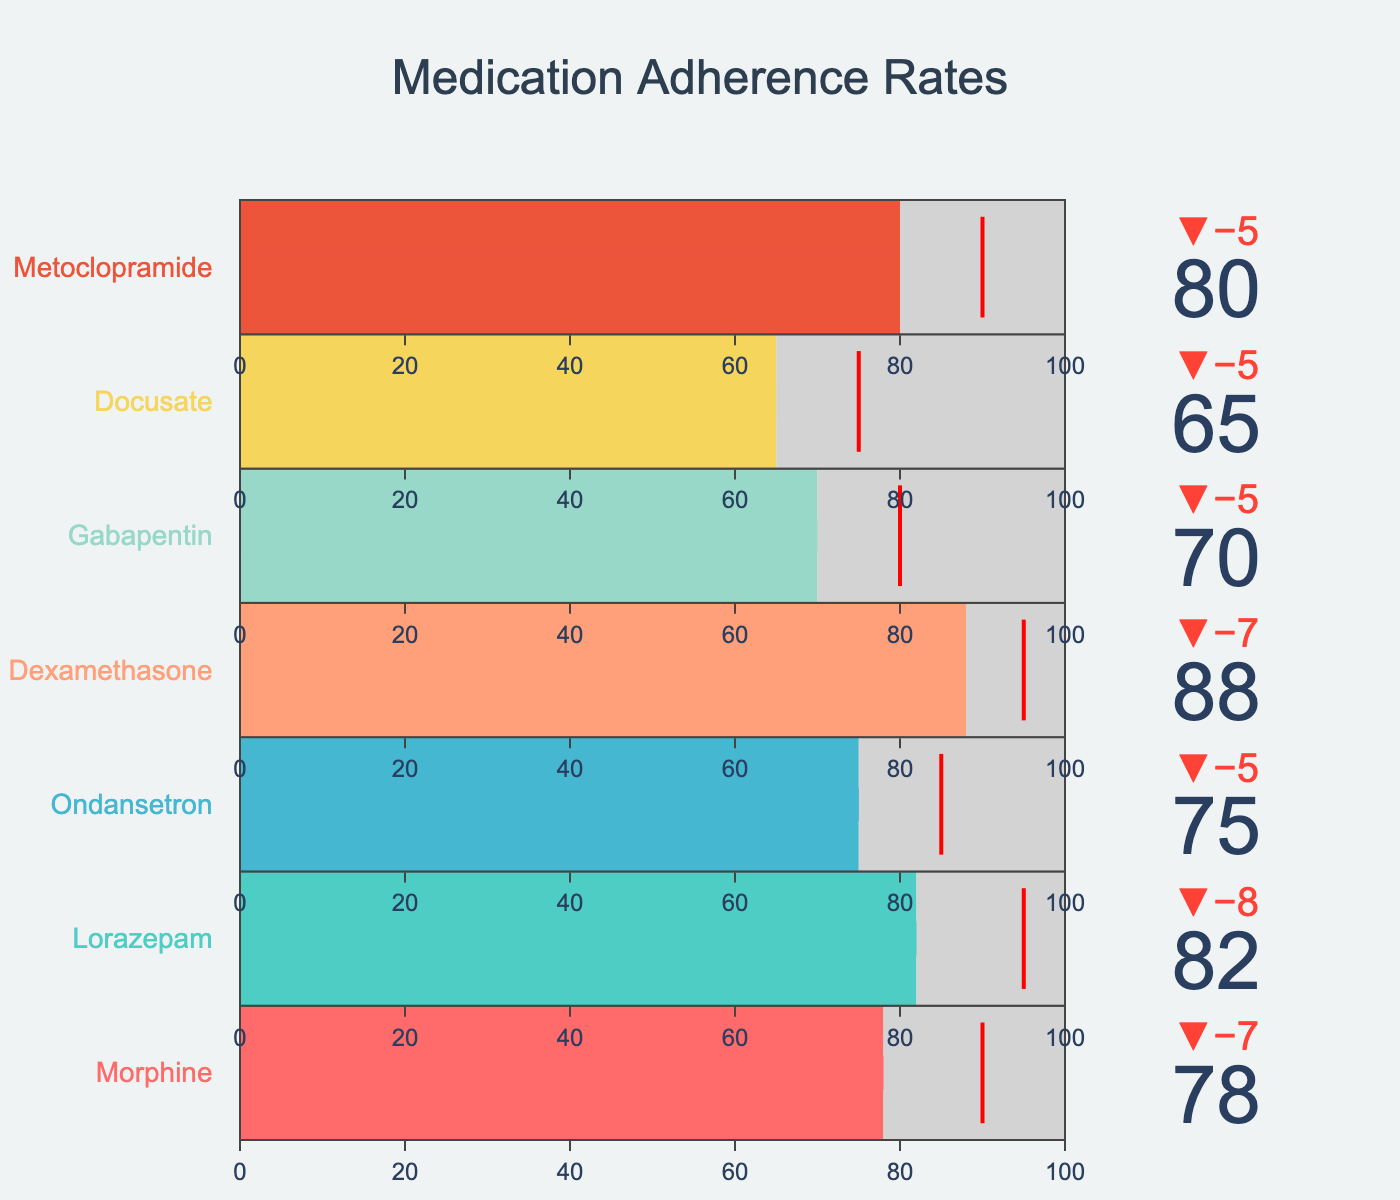What medication has the highest adherence rate? The adherence rates for each medication are shown in the bars. The medication with the highest actual adherence rate is Dexamethasone.
Answer: Dexamethasone How much lower is the actual adherence of Metoclopramide compared to its prescribed schedule? The actual adherence of Metoclopramide is 80, and its prescribed schedule is 85. The difference can be calculated as 85 - 80.
Answer: 5 Which medication has the smallest difference between actual adherence and target adherence? We need to calculate the difference between actual adherence and target adherence for each medication. Gabapentin has an actual adherence of 70 and a target of 80, for a difference of 10, which is the smallest difference.
Answer: Gabapentin How many medications have an actual adherence rate greater than 75? We count the number of medications where the actual adherence rate is greater than 75: Morphine (78), Lorazepam (82), Dexamethasone (88), and Metoclopramide (80).
Answer: 4 What is the average actual adherence rate across all medications? The actual adherence rates are 78, 82, 75, 88, 70, 65, and 80. To find the average, sum these values and divide by the number of medications. (78+82+75+88+70+65+80)/7 = 76.57 ≈ 76.6
Answer: 76.6 Which medication has the lowest actual adherence rate? The medication with the lowest actual adherence rate is identified by looking at the bars. Docusate has the lowest actual adherence rate of 65.
Answer: Docusate How many medications have met or exceeded their target adherence rates? We count the number of medications where actual adherence is equal to or greater than the target adherence. By reviewing the chart, it's clear that no medications meet or exceed their targets.
Answer: 0 Identify the medication with the largest gap between its actual adherence and target adherence. Calculate the differences between the actual adherence and target adherence for all medications. The largest gap is found with Ondansetron, where the difference is 85 - 75 = 10.
Answer: Ondansetron Which medication is closest to achieving its prescribed schedule? To answer this, compare the differences between actual adherence and prescribed schedule for all medications. Dexamethasone, with a difference of 95 - 88 = 7, is the closest.
Answer: Dexamethasone What is the total actual adherence rate of all medications combined? Sum up the actual adherence rates of all the medications: 78 + 82 + 75 + 88 + 70 + 65 + 80 = 538.
Answer: 538 